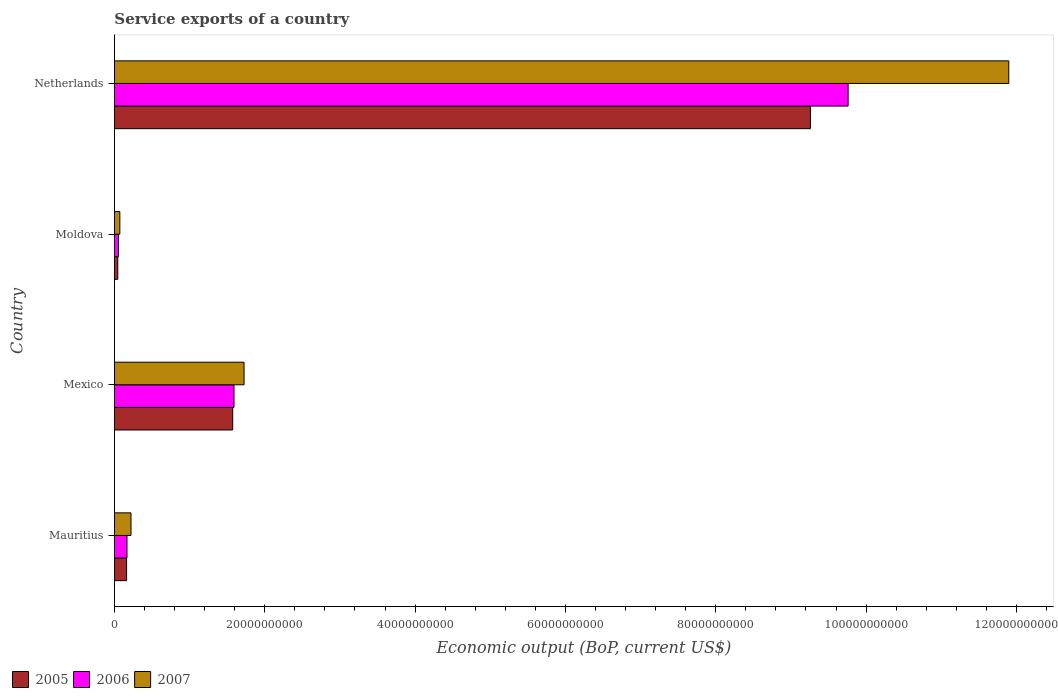How many groups of bars are there?
Provide a short and direct response. 4. Are the number of bars per tick equal to the number of legend labels?
Make the answer very short. Yes. Are the number of bars on each tick of the Y-axis equal?
Offer a terse response. Yes. How many bars are there on the 1st tick from the top?
Ensure brevity in your answer.  3. How many bars are there on the 1st tick from the bottom?
Offer a terse response. 3. What is the service exports in 2005 in Mexico?
Your response must be concise. 1.57e+1. Across all countries, what is the maximum service exports in 2007?
Give a very brief answer. 1.19e+11. Across all countries, what is the minimum service exports in 2007?
Provide a short and direct response. 7.19e+08. In which country was the service exports in 2007 maximum?
Make the answer very short. Netherlands. In which country was the service exports in 2005 minimum?
Your response must be concise. Moldova. What is the total service exports in 2005 in the graph?
Provide a short and direct response. 1.10e+11. What is the difference between the service exports in 2005 in Moldova and that in Netherlands?
Give a very brief answer. -9.21e+1. What is the difference between the service exports in 2007 in Moldova and the service exports in 2005 in Mauritius?
Your answer should be very brief. -8.99e+08. What is the average service exports in 2007 per country?
Ensure brevity in your answer.  3.48e+1. What is the difference between the service exports in 2007 and service exports in 2006 in Moldova?
Provide a succinct answer. 1.84e+08. What is the ratio of the service exports in 2006 in Mauritius to that in Netherlands?
Offer a terse response. 0.02. Is the service exports in 2006 in Mexico less than that in Moldova?
Make the answer very short. No. What is the difference between the highest and the second highest service exports in 2005?
Provide a short and direct response. 7.69e+1. What is the difference between the highest and the lowest service exports in 2007?
Ensure brevity in your answer.  1.18e+11. Is the sum of the service exports in 2007 in Mexico and Moldova greater than the maximum service exports in 2005 across all countries?
Your answer should be compact. No. What does the 1st bar from the top in Mexico represents?
Offer a terse response. 2007. What does the 2nd bar from the bottom in Mexico represents?
Offer a very short reply. 2006. How many bars are there?
Make the answer very short. 12. What is the difference between two consecutive major ticks on the X-axis?
Make the answer very short. 2.00e+1. Does the graph contain grids?
Make the answer very short. No. What is the title of the graph?
Provide a succinct answer. Service exports of a country. What is the label or title of the X-axis?
Provide a short and direct response. Economic output (BoP, current US$). What is the label or title of the Y-axis?
Your response must be concise. Country. What is the Economic output (BoP, current US$) in 2005 in Mauritius?
Your answer should be very brief. 1.62e+09. What is the Economic output (BoP, current US$) in 2006 in Mauritius?
Give a very brief answer. 1.67e+09. What is the Economic output (BoP, current US$) of 2007 in Mauritius?
Your answer should be compact. 2.21e+09. What is the Economic output (BoP, current US$) in 2005 in Mexico?
Provide a short and direct response. 1.57e+1. What is the Economic output (BoP, current US$) in 2006 in Mexico?
Provide a short and direct response. 1.59e+1. What is the Economic output (BoP, current US$) in 2007 in Mexico?
Offer a terse response. 1.72e+1. What is the Economic output (BoP, current US$) of 2005 in Moldova?
Keep it short and to the point. 4.46e+08. What is the Economic output (BoP, current US$) in 2006 in Moldova?
Ensure brevity in your answer.  5.35e+08. What is the Economic output (BoP, current US$) of 2007 in Moldova?
Keep it short and to the point. 7.19e+08. What is the Economic output (BoP, current US$) in 2005 in Netherlands?
Give a very brief answer. 9.26e+1. What is the Economic output (BoP, current US$) of 2006 in Netherlands?
Provide a short and direct response. 9.76e+1. What is the Economic output (BoP, current US$) in 2007 in Netherlands?
Ensure brevity in your answer.  1.19e+11. Across all countries, what is the maximum Economic output (BoP, current US$) of 2005?
Your answer should be very brief. 9.26e+1. Across all countries, what is the maximum Economic output (BoP, current US$) of 2006?
Your answer should be compact. 9.76e+1. Across all countries, what is the maximum Economic output (BoP, current US$) in 2007?
Provide a succinct answer. 1.19e+11. Across all countries, what is the minimum Economic output (BoP, current US$) of 2005?
Give a very brief answer. 4.46e+08. Across all countries, what is the minimum Economic output (BoP, current US$) of 2006?
Ensure brevity in your answer.  5.35e+08. Across all countries, what is the minimum Economic output (BoP, current US$) in 2007?
Your answer should be very brief. 7.19e+08. What is the total Economic output (BoP, current US$) in 2005 in the graph?
Your response must be concise. 1.10e+11. What is the total Economic output (BoP, current US$) in 2006 in the graph?
Your answer should be very brief. 1.16e+11. What is the total Economic output (BoP, current US$) of 2007 in the graph?
Give a very brief answer. 1.39e+11. What is the difference between the Economic output (BoP, current US$) in 2005 in Mauritius and that in Mexico?
Provide a succinct answer. -1.41e+1. What is the difference between the Economic output (BoP, current US$) of 2006 in Mauritius and that in Mexico?
Keep it short and to the point. -1.42e+1. What is the difference between the Economic output (BoP, current US$) of 2007 in Mauritius and that in Mexico?
Provide a succinct answer. -1.50e+1. What is the difference between the Economic output (BoP, current US$) in 2005 in Mauritius and that in Moldova?
Your answer should be very brief. 1.17e+09. What is the difference between the Economic output (BoP, current US$) in 2006 in Mauritius and that in Moldova?
Give a very brief answer. 1.14e+09. What is the difference between the Economic output (BoP, current US$) in 2007 in Mauritius and that in Moldova?
Ensure brevity in your answer.  1.49e+09. What is the difference between the Economic output (BoP, current US$) in 2005 in Mauritius and that in Netherlands?
Your answer should be very brief. -9.10e+1. What is the difference between the Economic output (BoP, current US$) of 2006 in Mauritius and that in Netherlands?
Your answer should be compact. -9.59e+1. What is the difference between the Economic output (BoP, current US$) in 2007 in Mauritius and that in Netherlands?
Provide a short and direct response. -1.17e+11. What is the difference between the Economic output (BoP, current US$) in 2005 in Mexico and that in Moldova?
Your answer should be compact. 1.53e+1. What is the difference between the Economic output (BoP, current US$) of 2006 in Mexico and that in Moldova?
Your response must be concise. 1.54e+1. What is the difference between the Economic output (BoP, current US$) in 2007 in Mexico and that in Moldova?
Ensure brevity in your answer.  1.65e+1. What is the difference between the Economic output (BoP, current US$) in 2005 in Mexico and that in Netherlands?
Your answer should be very brief. -7.69e+1. What is the difference between the Economic output (BoP, current US$) of 2006 in Mexico and that in Netherlands?
Give a very brief answer. -8.17e+1. What is the difference between the Economic output (BoP, current US$) of 2007 in Mexico and that in Netherlands?
Make the answer very short. -1.02e+11. What is the difference between the Economic output (BoP, current US$) of 2005 in Moldova and that in Netherlands?
Give a very brief answer. -9.21e+1. What is the difference between the Economic output (BoP, current US$) of 2006 in Moldova and that in Netherlands?
Provide a succinct answer. -9.71e+1. What is the difference between the Economic output (BoP, current US$) of 2007 in Moldova and that in Netherlands?
Provide a succinct answer. -1.18e+11. What is the difference between the Economic output (BoP, current US$) of 2005 in Mauritius and the Economic output (BoP, current US$) of 2006 in Mexico?
Your answer should be very brief. -1.43e+1. What is the difference between the Economic output (BoP, current US$) of 2005 in Mauritius and the Economic output (BoP, current US$) of 2007 in Mexico?
Ensure brevity in your answer.  -1.56e+1. What is the difference between the Economic output (BoP, current US$) in 2006 in Mauritius and the Economic output (BoP, current US$) in 2007 in Mexico?
Offer a very short reply. -1.56e+1. What is the difference between the Economic output (BoP, current US$) of 2005 in Mauritius and the Economic output (BoP, current US$) of 2006 in Moldova?
Keep it short and to the point. 1.08e+09. What is the difference between the Economic output (BoP, current US$) of 2005 in Mauritius and the Economic output (BoP, current US$) of 2007 in Moldova?
Make the answer very short. 8.99e+08. What is the difference between the Economic output (BoP, current US$) of 2006 in Mauritius and the Economic output (BoP, current US$) of 2007 in Moldova?
Make the answer very short. 9.52e+08. What is the difference between the Economic output (BoP, current US$) of 2005 in Mauritius and the Economic output (BoP, current US$) of 2006 in Netherlands?
Provide a short and direct response. -9.60e+1. What is the difference between the Economic output (BoP, current US$) in 2005 in Mauritius and the Economic output (BoP, current US$) in 2007 in Netherlands?
Your answer should be compact. -1.17e+11. What is the difference between the Economic output (BoP, current US$) in 2006 in Mauritius and the Economic output (BoP, current US$) in 2007 in Netherlands?
Provide a short and direct response. -1.17e+11. What is the difference between the Economic output (BoP, current US$) in 2005 in Mexico and the Economic output (BoP, current US$) in 2006 in Moldova?
Offer a very short reply. 1.52e+1. What is the difference between the Economic output (BoP, current US$) of 2005 in Mexico and the Economic output (BoP, current US$) of 2007 in Moldova?
Keep it short and to the point. 1.50e+1. What is the difference between the Economic output (BoP, current US$) of 2006 in Mexico and the Economic output (BoP, current US$) of 2007 in Moldova?
Keep it short and to the point. 1.52e+1. What is the difference between the Economic output (BoP, current US$) of 2005 in Mexico and the Economic output (BoP, current US$) of 2006 in Netherlands?
Make the answer very short. -8.19e+1. What is the difference between the Economic output (BoP, current US$) in 2005 in Mexico and the Economic output (BoP, current US$) in 2007 in Netherlands?
Ensure brevity in your answer.  -1.03e+11. What is the difference between the Economic output (BoP, current US$) of 2006 in Mexico and the Economic output (BoP, current US$) of 2007 in Netherlands?
Offer a terse response. -1.03e+11. What is the difference between the Economic output (BoP, current US$) in 2005 in Moldova and the Economic output (BoP, current US$) in 2006 in Netherlands?
Your answer should be compact. -9.72e+1. What is the difference between the Economic output (BoP, current US$) in 2005 in Moldova and the Economic output (BoP, current US$) in 2007 in Netherlands?
Provide a short and direct response. -1.19e+11. What is the difference between the Economic output (BoP, current US$) of 2006 in Moldova and the Economic output (BoP, current US$) of 2007 in Netherlands?
Keep it short and to the point. -1.18e+11. What is the average Economic output (BoP, current US$) in 2005 per country?
Offer a terse response. 2.76e+1. What is the average Economic output (BoP, current US$) of 2006 per country?
Your answer should be very brief. 2.89e+1. What is the average Economic output (BoP, current US$) in 2007 per country?
Make the answer very short. 3.48e+1. What is the difference between the Economic output (BoP, current US$) of 2005 and Economic output (BoP, current US$) of 2006 in Mauritius?
Provide a succinct answer. -5.32e+07. What is the difference between the Economic output (BoP, current US$) in 2005 and Economic output (BoP, current US$) in 2007 in Mauritius?
Ensure brevity in your answer.  -5.87e+08. What is the difference between the Economic output (BoP, current US$) of 2006 and Economic output (BoP, current US$) of 2007 in Mauritius?
Provide a succinct answer. -5.34e+08. What is the difference between the Economic output (BoP, current US$) in 2005 and Economic output (BoP, current US$) in 2006 in Mexico?
Your answer should be very brief. -1.73e+08. What is the difference between the Economic output (BoP, current US$) of 2005 and Economic output (BoP, current US$) of 2007 in Mexico?
Your answer should be very brief. -1.51e+09. What is the difference between the Economic output (BoP, current US$) of 2006 and Economic output (BoP, current US$) of 2007 in Mexico?
Your response must be concise. -1.34e+09. What is the difference between the Economic output (BoP, current US$) of 2005 and Economic output (BoP, current US$) of 2006 in Moldova?
Ensure brevity in your answer.  -8.90e+07. What is the difference between the Economic output (BoP, current US$) in 2005 and Economic output (BoP, current US$) in 2007 in Moldova?
Your response must be concise. -2.73e+08. What is the difference between the Economic output (BoP, current US$) in 2006 and Economic output (BoP, current US$) in 2007 in Moldova?
Your response must be concise. -1.84e+08. What is the difference between the Economic output (BoP, current US$) of 2005 and Economic output (BoP, current US$) of 2006 in Netherlands?
Provide a short and direct response. -5.02e+09. What is the difference between the Economic output (BoP, current US$) of 2005 and Economic output (BoP, current US$) of 2007 in Netherlands?
Ensure brevity in your answer.  -2.64e+1. What is the difference between the Economic output (BoP, current US$) in 2006 and Economic output (BoP, current US$) in 2007 in Netherlands?
Provide a short and direct response. -2.14e+1. What is the ratio of the Economic output (BoP, current US$) in 2005 in Mauritius to that in Mexico?
Offer a very short reply. 0.1. What is the ratio of the Economic output (BoP, current US$) in 2006 in Mauritius to that in Mexico?
Your answer should be compact. 0.11. What is the ratio of the Economic output (BoP, current US$) in 2007 in Mauritius to that in Mexico?
Provide a succinct answer. 0.13. What is the ratio of the Economic output (BoP, current US$) of 2005 in Mauritius to that in Moldova?
Your answer should be very brief. 3.63. What is the ratio of the Economic output (BoP, current US$) of 2006 in Mauritius to that in Moldova?
Offer a very short reply. 3.12. What is the ratio of the Economic output (BoP, current US$) in 2007 in Mauritius to that in Moldova?
Make the answer very short. 3.07. What is the ratio of the Economic output (BoP, current US$) in 2005 in Mauritius to that in Netherlands?
Your answer should be compact. 0.02. What is the ratio of the Economic output (BoP, current US$) of 2006 in Mauritius to that in Netherlands?
Give a very brief answer. 0.02. What is the ratio of the Economic output (BoP, current US$) of 2007 in Mauritius to that in Netherlands?
Your answer should be compact. 0.02. What is the ratio of the Economic output (BoP, current US$) in 2005 in Mexico to that in Moldova?
Make the answer very short. 35.27. What is the ratio of the Economic output (BoP, current US$) in 2006 in Mexico to that in Moldova?
Offer a very short reply. 29.73. What is the ratio of the Economic output (BoP, current US$) of 2007 in Mexico to that in Moldova?
Offer a terse response. 23.97. What is the ratio of the Economic output (BoP, current US$) of 2005 in Mexico to that in Netherlands?
Your answer should be very brief. 0.17. What is the ratio of the Economic output (BoP, current US$) in 2006 in Mexico to that in Netherlands?
Your response must be concise. 0.16. What is the ratio of the Economic output (BoP, current US$) in 2007 in Mexico to that in Netherlands?
Provide a short and direct response. 0.14. What is the ratio of the Economic output (BoP, current US$) in 2005 in Moldova to that in Netherlands?
Offer a terse response. 0. What is the ratio of the Economic output (BoP, current US$) in 2006 in Moldova to that in Netherlands?
Provide a short and direct response. 0.01. What is the ratio of the Economic output (BoP, current US$) in 2007 in Moldova to that in Netherlands?
Give a very brief answer. 0.01. What is the difference between the highest and the second highest Economic output (BoP, current US$) of 2005?
Provide a succinct answer. 7.69e+1. What is the difference between the highest and the second highest Economic output (BoP, current US$) of 2006?
Make the answer very short. 8.17e+1. What is the difference between the highest and the second highest Economic output (BoP, current US$) in 2007?
Give a very brief answer. 1.02e+11. What is the difference between the highest and the lowest Economic output (BoP, current US$) in 2005?
Ensure brevity in your answer.  9.21e+1. What is the difference between the highest and the lowest Economic output (BoP, current US$) in 2006?
Make the answer very short. 9.71e+1. What is the difference between the highest and the lowest Economic output (BoP, current US$) in 2007?
Ensure brevity in your answer.  1.18e+11. 